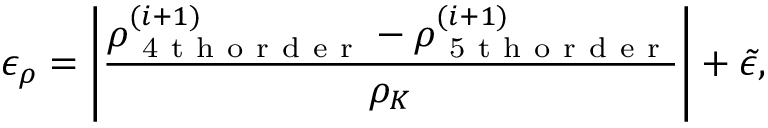Convert formula to latex. <formula><loc_0><loc_0><loc_500><loc_500>\epsilon _ { \rho } = \left | \frac { \rho _ { 4 t h o r d e r } ^ { ( i + 1 ) } - \rho _ { 5 t h o r d e r } ^ { ( i + 1 ) } } { \rho _ { K } } \right | + \tilde { \epsilon } ,</formula> 